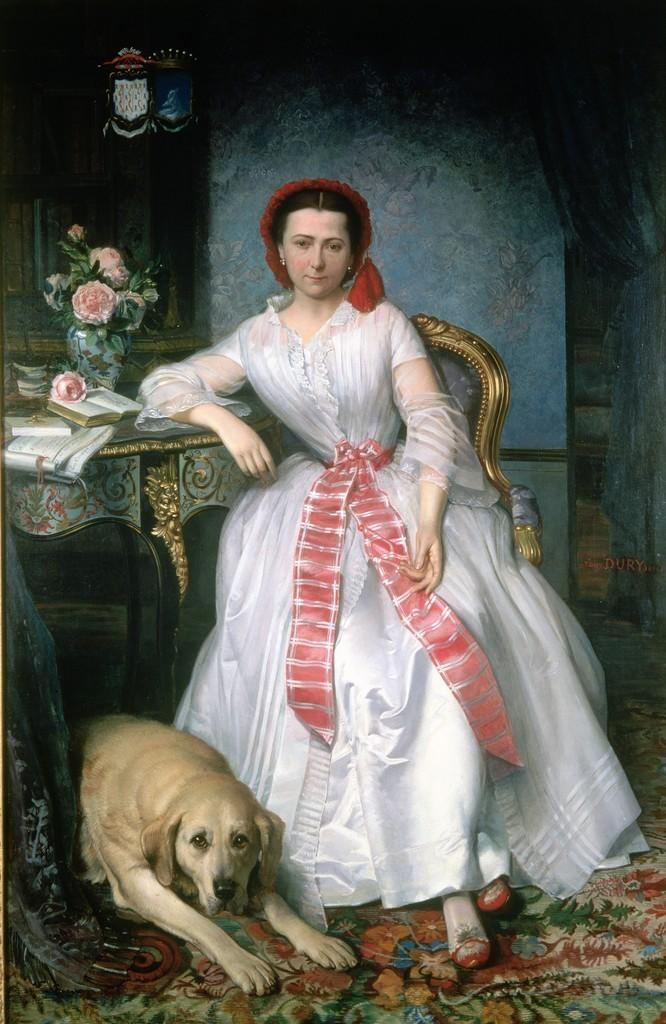What type of artwork is depicted in the image? The image is a painting. Can you describe the main subject of the painting? There is a beautiful woman in the painting. What is the woman doing in the painting? The woman is sitting on a chair. What is the woman wearing in the painting? The woman is wearing a white dress. Are there any other living beings in the painting? Yes, there is a dog in the painting. Where is the dog located in the painting? The dog is sitting on the floor. What is the minister coughing about in the painting? There is no minister present in the painting, and therefore no one is coughing. 